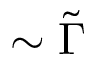Convert formula to latex. <formula><loc_0><loc_0><loc_500><loc_500>\sim \tilde { \Gamma }</formula> 